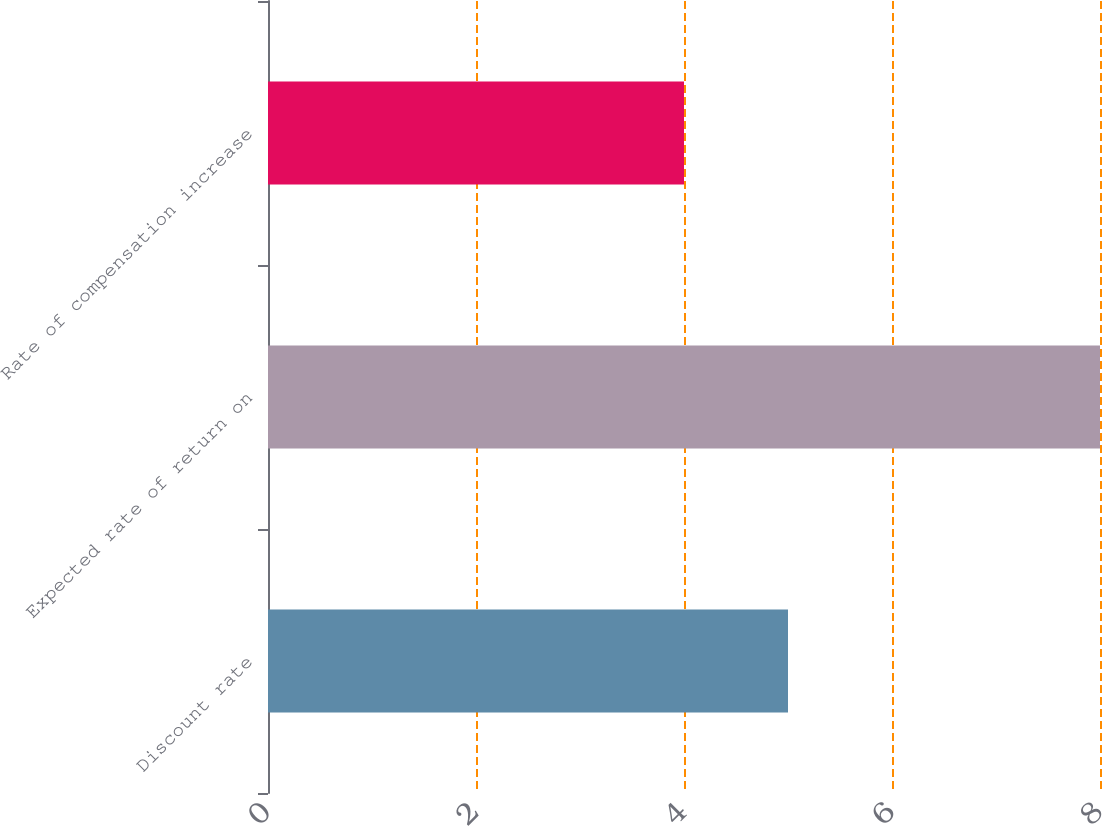Convert chart. <chart><loc_0><loc_0><loc_500><loc_500><bar_chart><fcel>Discount rate<fcel>Expected rate of return on<fcel>Rate of compensation increase<nl><fcel>5<fcel>8<fcel>4<nl></chart> 